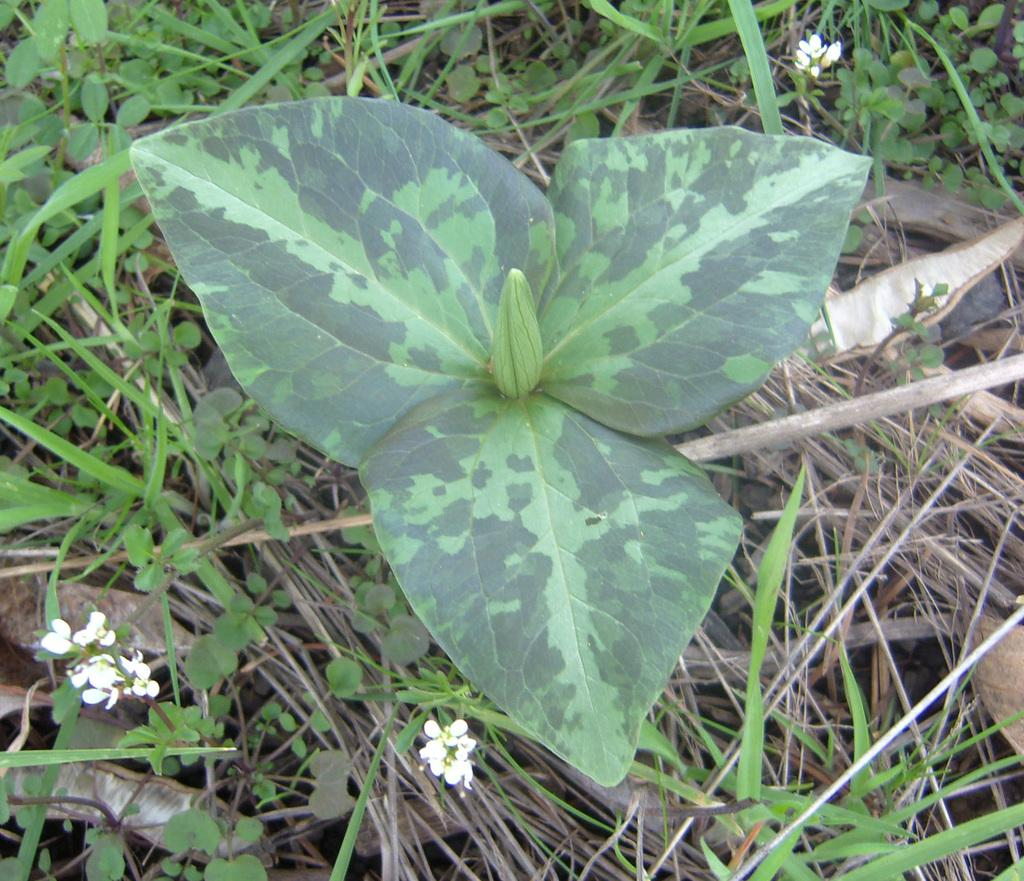What is the main subject in the center of the image? There is a plant in the center of the image. What additional features can be seen on the plant? There are flowers visible on the plant. What type of vegetation is present in the image? There is grass in the image. What type of unit is being requested in the image? There is no mention of a unit or request in the image; it features a plant with flowers and grass. 